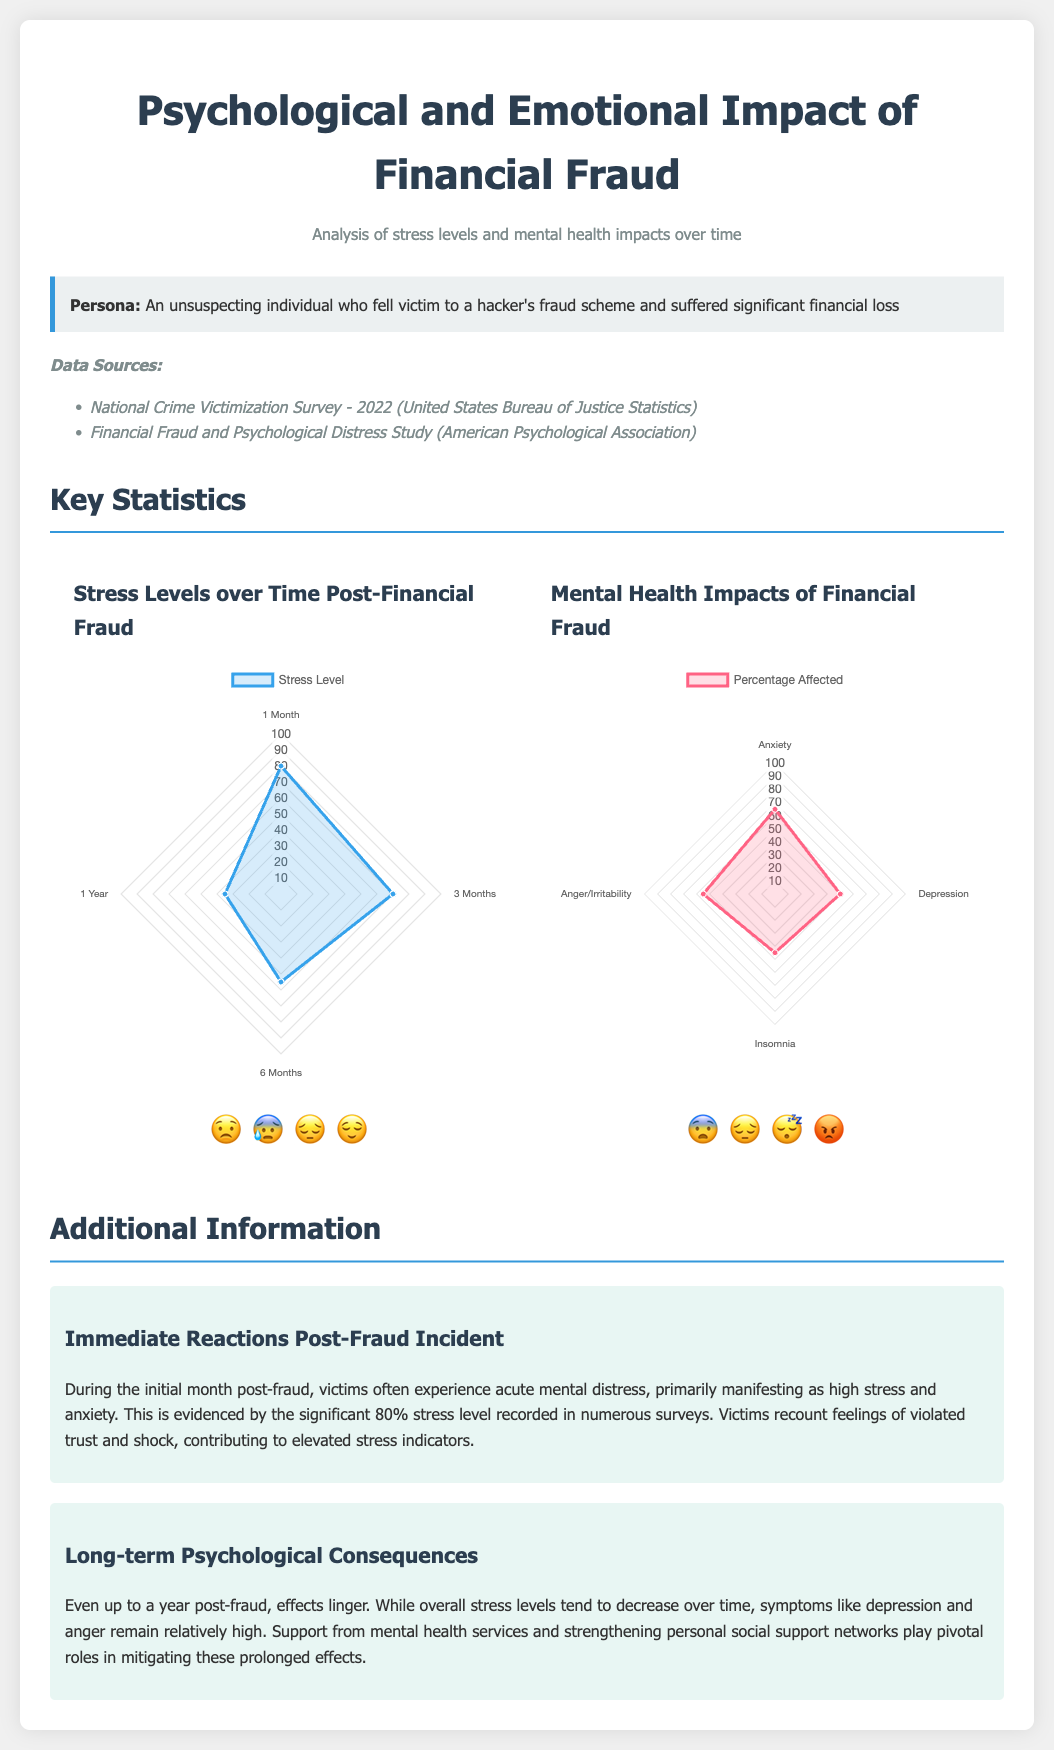What is the maximum stress level recorded? The maximum stress level recorded in the surveys was during the initial month post-fraud, which was 80%.
Answer: 80% What percentage of victims experienced anxiety? According to the mental health impacts chart, 65% of victims reported experiencing anxiety.
Answer: 65% What is the typical duration referenced for measuring stress levels post-fraud? The document references four time durations for measuring stress levels: 1 Month, 3 Months, 6 Months, and 1 Year.
Answer: 1 Month, 3 Months, 6 Months, 1 Year What emotion is represented by the emotive icon for high stress? The emotive icon representing high stress levels is the stressed face emoji, which appears as 😟.
Answer: 😟 What is the suggested minimum for the stress levels chart? The suggested minimum for the stress levels chart is 0.
Answer: 0 What are the two main data sources listed in the document? The two main data sources are the National Crime Victimization Survey - 2022 and the Financial Fraud and Psychological Distress Study.
Answer: National Crime Victimization Survey - 2022, Financial Fraud and Psychological Distress Study What is the trend observed in stress levels over time? The trend observed shows that stress levels decrease over time post-fraud, dropping from 80% to 35%.
Answer: Decrease over time What percentage of victims reported depression? The mental health impacts chart shows that 50% of victims reported experiencing depression.
Answer: 50% What sentiment encapsulates the persona's experience? The persona's experience is characterized by feelings of violated trust and shock.
Answer: Violated trust and shock 